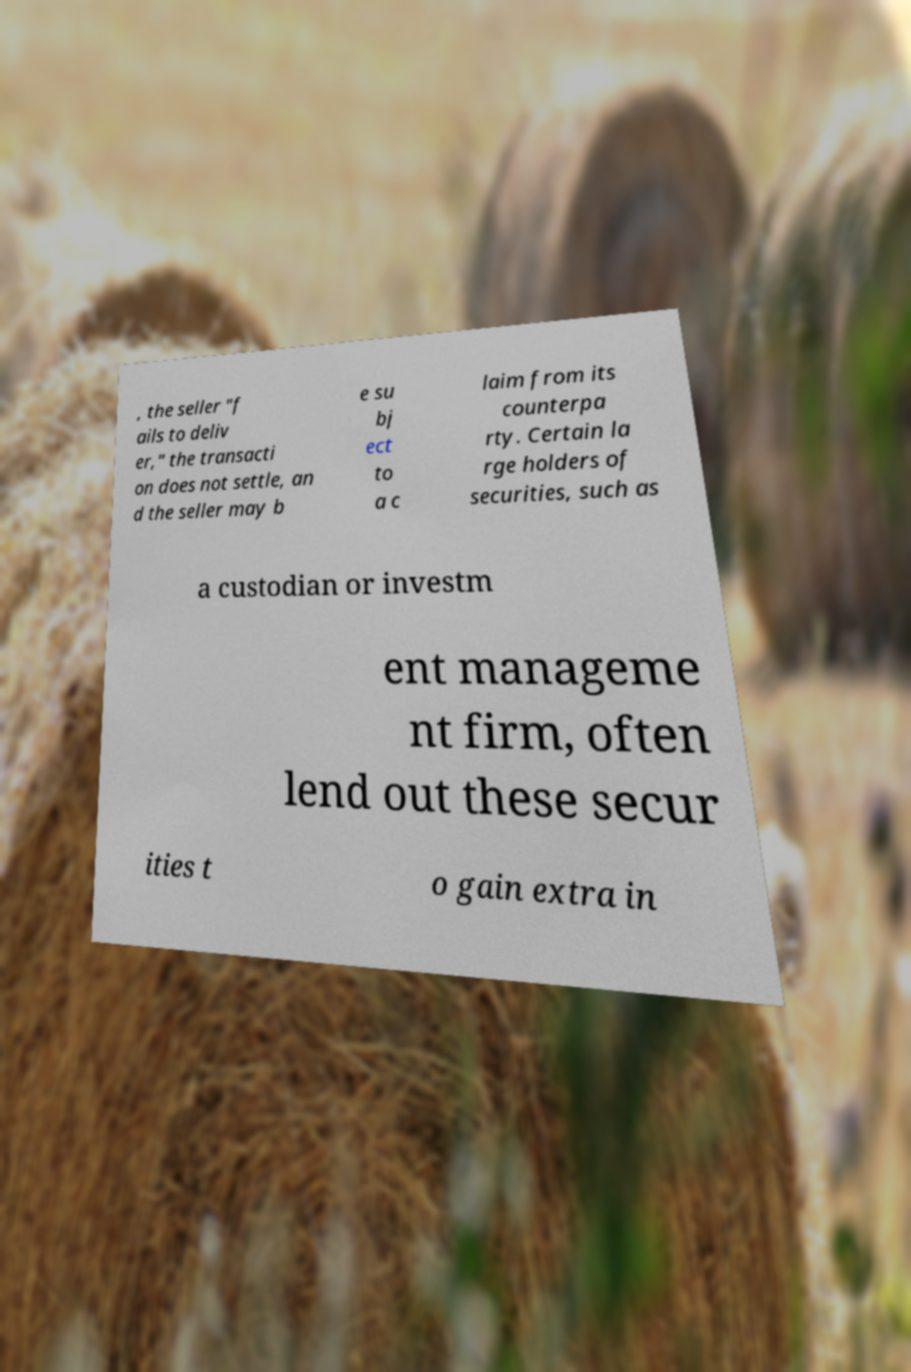Please read and relay the text visible in this image. What does it say? , the seller "f ails to deliv er," the transacti on does not settle, an d the seller may b e su bj ect to a c laim from its counterpa rty. Certain la rge holders of securities, such as a custodian or investm ent manageme nt firm, often lend out these secur ities t o gain extra in 